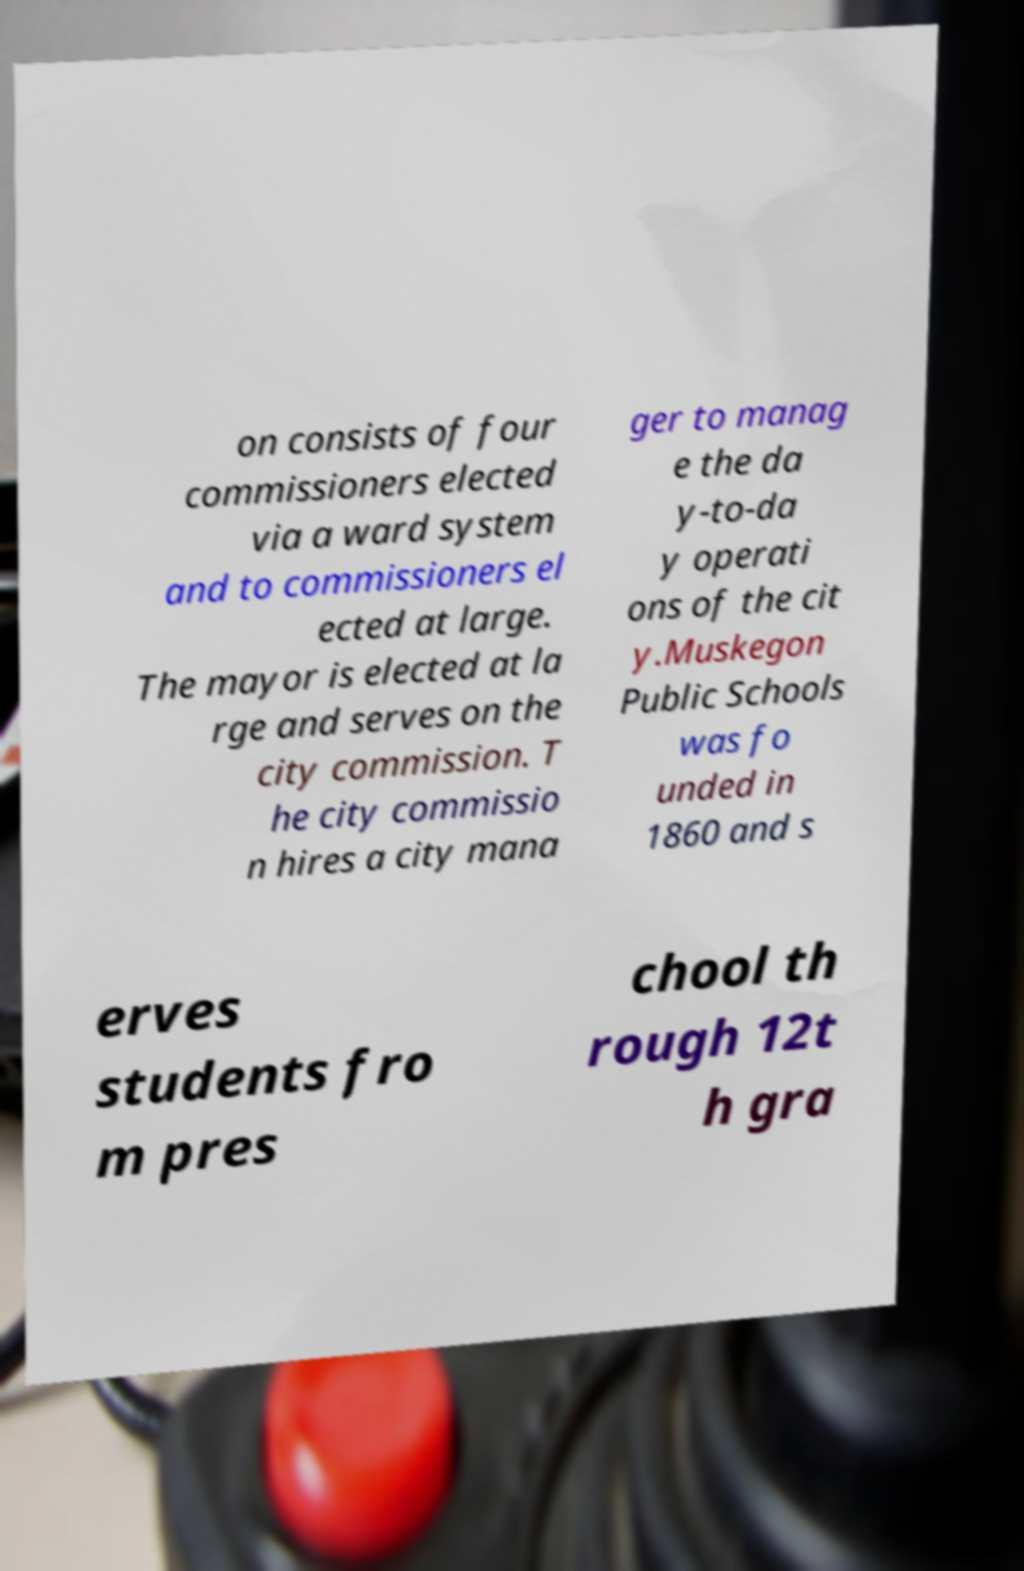Could you extract and type out the text from this image? on consists of four commissioners elected via a ward system and to commissioners el ected at large. The mayor is elected at la rge and serves on the city commission. T he city commissio n hires a city mana ger to manag e the da y-to-da y operati ons of the cit y.Muskegon Public Schools was fo unded in 1860 and s erves students fro m pres chool th rough 12t h gra 